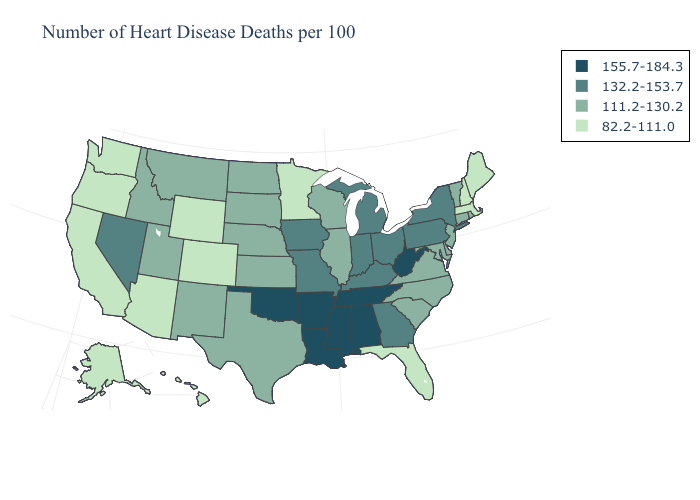Name the states that have a value in the range 111.2-130.2?
Answer briefly. Connecticut, Delaware, Idaho, Illinois, Kansas, Maryland, Montana, Nebraska, New Jersey, New Mexico, North Carolina, North Dakota, Rhode Island, South Carolina, South Dakota, Texas, Utah, Vermont, Virginia, Wisconsin. What is the value of Minnesota?
Write a very short answer. 82.2-111.0. Does Florida have the lowest value in the South?
Give a very brief answer. Yes. Among the states that border Maine , which have the highest value?
Short answer required. New Hampshire. Does the map have missing data?
Concise answer only. No. How many symbols are there in the legend?
Quick response, please. 4. Name the states that have a value in the range 82.2-111.0?
Answer briefly. Alaska, Arizona, California, Colorado, Florida, Hawaii, Maine, Massachusetts, Minnesota, New Hampshire, Oregon, Washington, Wyoming. Name the states that have a value in the range 82.2-111.0?
Be succinct. Alaska, Arizona, California, Colorado, Florida, Hawaii, Maine, Massachusetts, Minnesota, New Hampshire, Oregon, Washington, Wyoming. What is the value of Oregon?
Give a very brief answer. 82.2-111.0. What is the value of North Carolina?
Quick response, please. 111.2-130.2. Does South Carolina have the highest value in the USA?
Write a very short answer. No. Does Delaware have the highest value in the South?
Write a very short answer. No. What is the value of Delaware?
Answer briefly. 111.2-130.2. What is the highest value in the USA?
Give a very brief answer. 155.7-184.3. What is the highest value in the South ?
Write a very short answer. 155.7-184.3. 